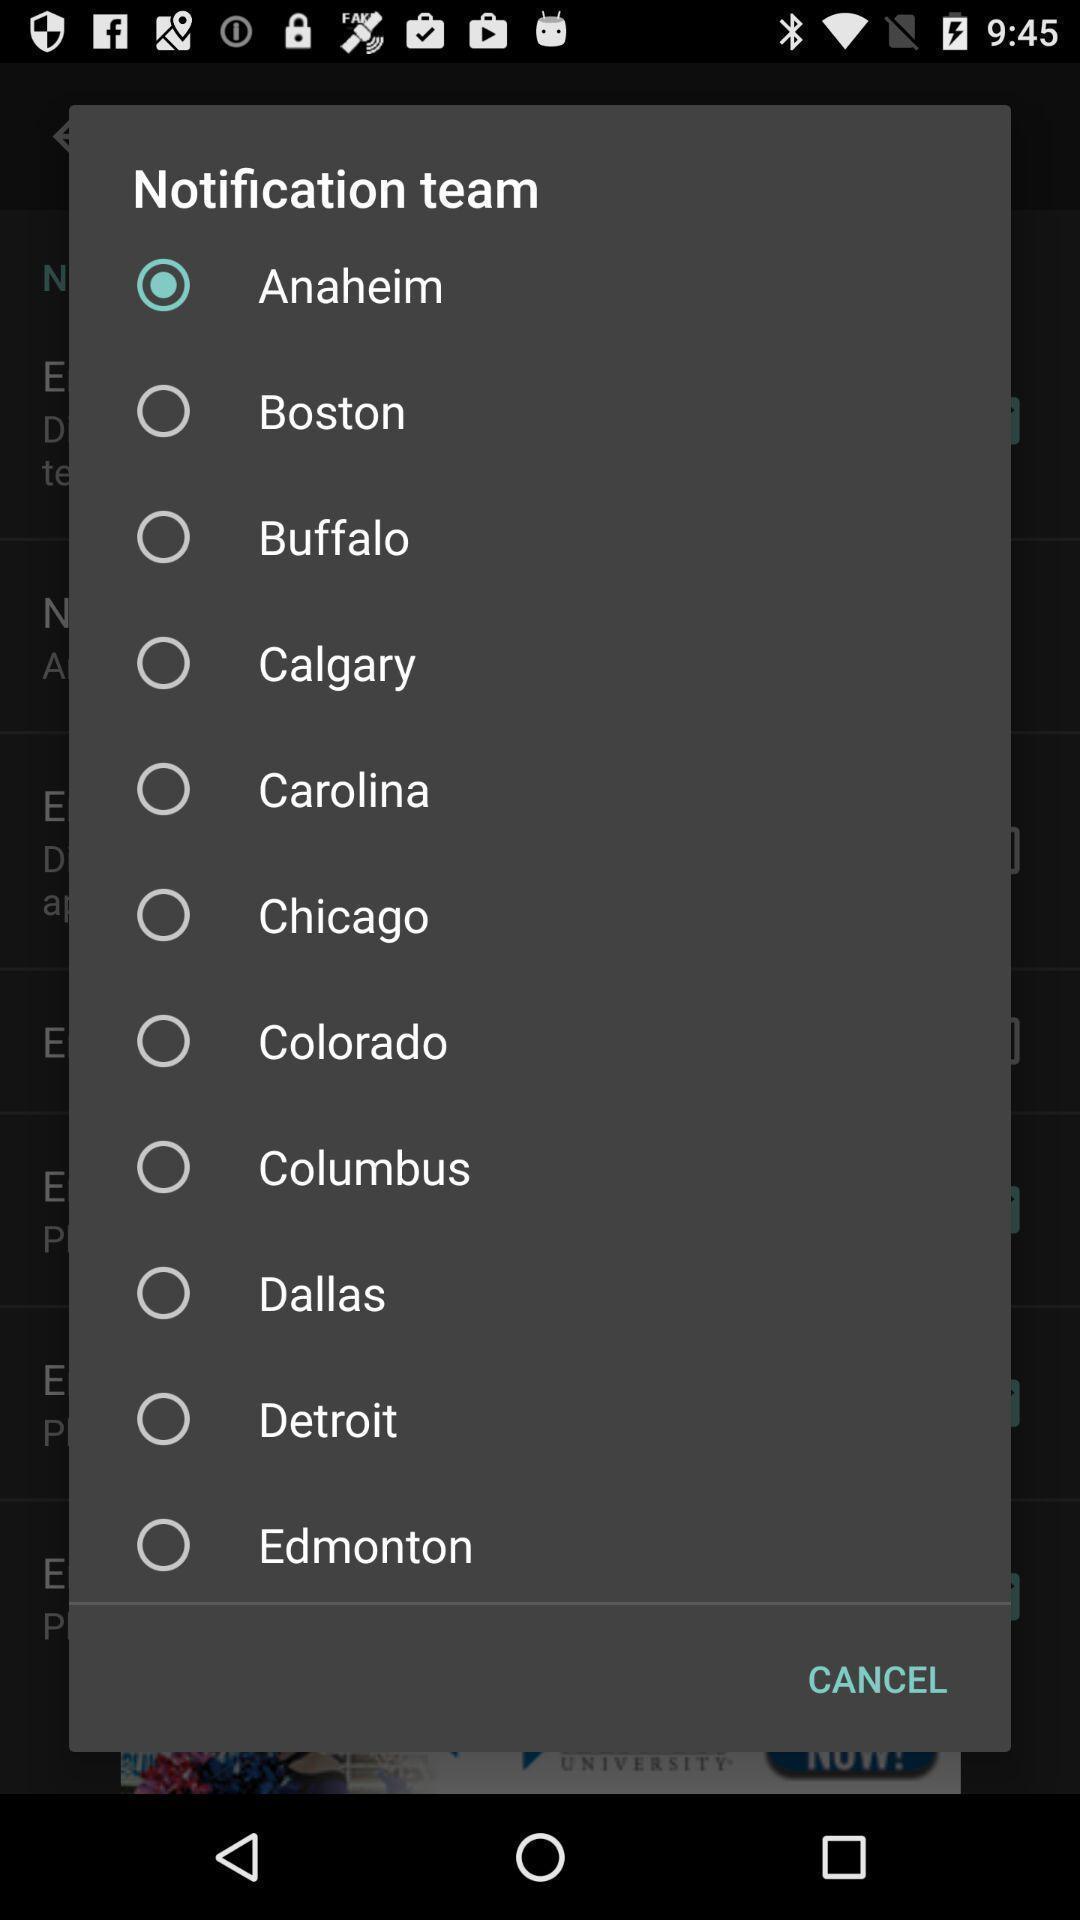Provide a description of this screenshot. Popup showing team options to select. 